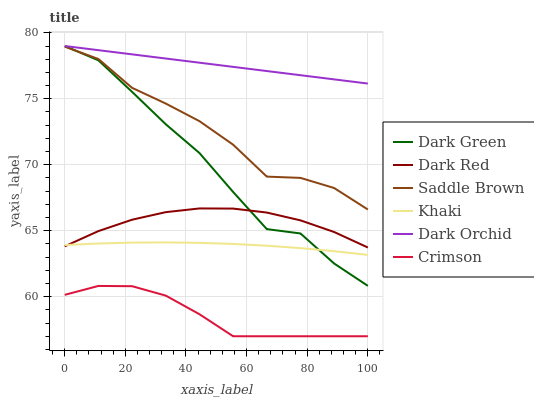Does Crimson have the minimum area under the curve?
Answer yes or no. Yes. Does Dark Orchid have the maximum area under the curve?
Answer yes or no. Yes. Does Dark Red have the minimum area under the curve?
Answer yes or no. No. Does Dark Red have the maximum area under the curve?
Answer yes or no. No. Is Dark Orchid the smoothest?
Answer yes or no. Yes. Is Dark Green the roughest?
Answer yes or no. Yes. Is Dark Red the smoothest?
Answer yes or no. No. Is Dark Red the roughest?
Answer yes or no. No. Does Dark Red have the lowest value?
Answer yes or no. No. Does Dark Red have the highest value?
Answer yes or no. No. Is Crimson less than Saddle Brown?
Answer yes or no. Yes. Is Saddle Brown greater than Crimson?
Answer yes or no. Yes. Does Crimson intersect Saddle Brown?
Answer yes or no. No. 